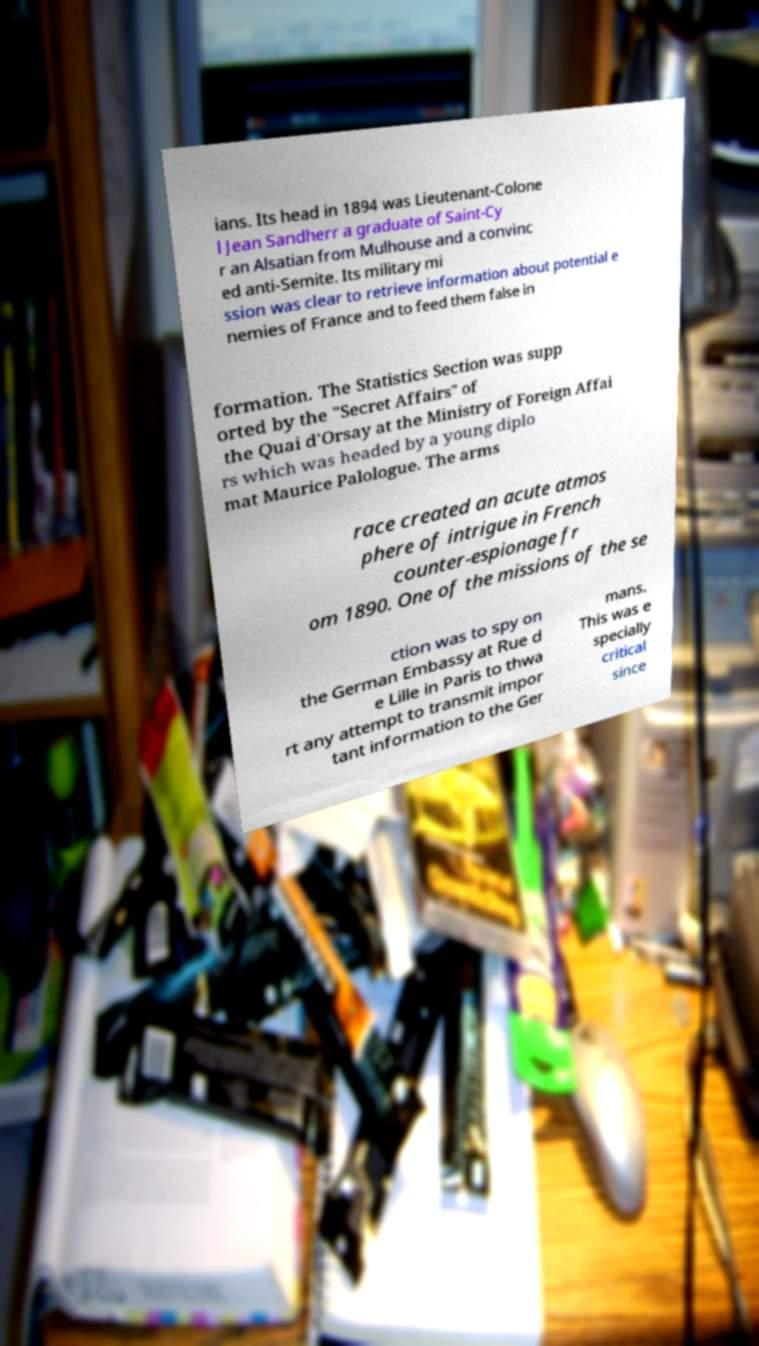What messages or text are displayed in this image? I need them in a readable, typed format. ians. Its head in 1894 was Lieutenant-Colone l Jean Sandherr a graduate of Saint-Cy r an Alsatian from Mulhouse and a convinc ed anti-Semite. Its military mi ssion was clear to retrieve information about potential e nemies of France and to feed them false in formation. The Statistics Section was supp orted by the "Secret Affairs" of the Quai d'Orsay at the Ministry of Foreign Affai rs which was headed by a young diplo mat Maurice Palologue. The arms race created an acute atmos phere of intrigue in French counter-espionage fr om 1890. One of the missions of the se ction was to spy on the German Embassy at Rue d e Lille in Paris to thwa rt any attempt to transmit impor tant information to the Ger mans. This was e specially critical since 